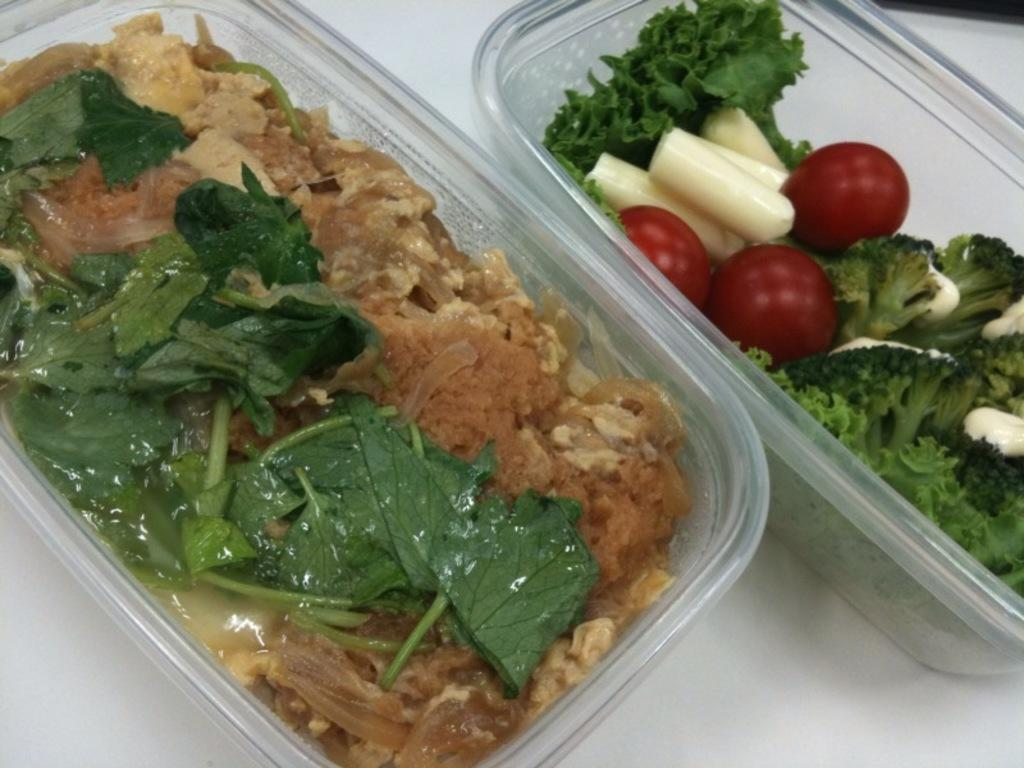What is the main object in the image? There is a table in the image. What is placed on the table? There are boxes on the table. What are the contents of the boxes? The boxes contain vegetables. What type of spade is used to process the vegetables in the image? There is no spade or process of vegetable processing visible in the image. 